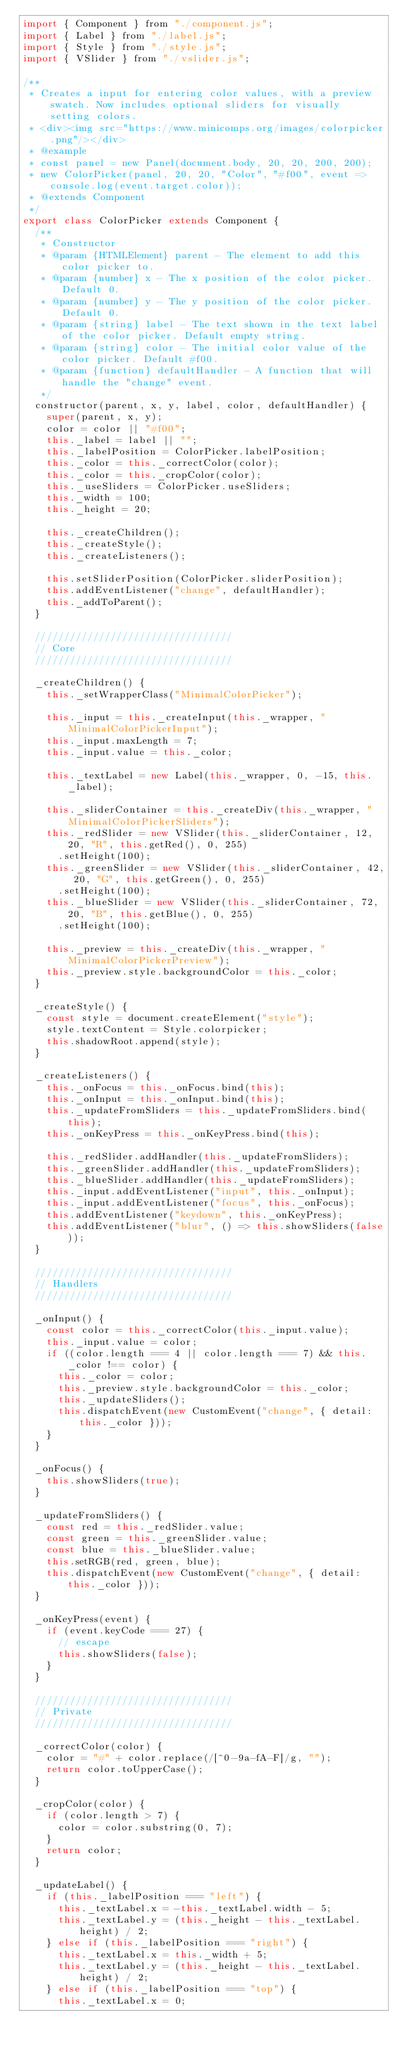<code> <loc_0><loc_0><loc_500><loc_500><_JavaScript_>import { Component } from "./component.js";
import { Label } from "./label.js";
import { Style } from "./style.js";
import { VSlider } from "./vslider.js";

/**
 * Creates a input for entering color values, with a preview swatch. Now includes optional sliders for visually setting colors.
 * <div><img src="https://www.minicomps.org/images/colorpicker.png"/></div>
 * @example
 * const panel = new Panel(document.body, 20, 20, 200, 200);
 * new ColorPicker(panel, 20, 20, "Color", "#f00", event => console.log(event.target.color));
 * @extends Component
 */
export class ColorPicker extends Component {
  /**
   * Constructor
   * @param {HTMLElement} parent - The element to add this color picker to.
   * @param {number} x - The x position of the color picker. Default 0.
   * @param {number} y - The y position of the color picker. Default 0.
   * @param {string} label - The text shown in the text label of the color picker. Default empty string.
   * @param {string} color - The initial color value of the color picker. Default #f00.
   * @param {function} defaultHandler - A function that will handle the "change" event.
   */
  constructor(parent, x, y, label, color, defaultHandler) {
    super(parent, x, y);
    color = color || "#f00";
    this._label = label || "";
    this._labelPosition = ColorPicker.labelPosition;
    this._color = this._correctColor(color);
    this._color = this._cropColor(color);
    this._useSliders = ColorPicker.useSliders;
    this._width = 100;
    this._height = 20;

    this._createChildren();
    this._createStyle();
    this._createListeners();

    this.setSliderPosition(ColorPicker.sliderPosition);
    this.addEventListener("change", defaultHandler);
    this._addToParent();
  }

  //////////////////////////////////
  // Core
  //////////////////////////////////

  _createChildren() {
    this._setWrapperClass("MinimalColorPicker");

    this._input = this._createInput(this._wrapper, "MinimalColorPickerInput");
    this._input.maxLength = 7;
    this._input.value = this._color;

    this._textLabel = new Label(this._wrapper, 0, -15, this._label);

    this._sliderContainer = this._createDiv(this._wrapper, "MinimalColorPickerSliders");
    this._redSlider = new VSlider(this._sliderContainer, 12, 20, "R", this.getRed(), 0, 255)
      .setHeight(100);
    this._greenSlider = new VSlider(this._sliderContainer, 42, 20, "G", this.getGreen(), 0, 255)
      .setHeight(100);
    this._blueSlider = new VSlider(this._sliderContainer, 72, 20, "B", this.getBlue(), 0, 255)
      .setHeight(100);

    this._preview = this._createDiv(this._wrapper, "MinimalColorPickerPreview");
    this._preview.style.backgroundColor = this._color;
  }

  _createStyle() {
    const style = document.createElement("style");
    style.textContent = Style.colorpicker;
    this.shadowRoot.append(style);
  }

  _createListeners() {
    this._onFocus = this._onFocus.bind(this);
    this._onInput = this._onInput.bind(this);
    this._updateFromSliders = this._updateFromSliders.bind(this);
    this._onKeyPress = this._onKeyPress.bind(this);

    this._redSlider.addHandler(this._updateFromSliders);
    this._greenSlider.addHandler(this._updateFromSliders);
    this._blueSlider.addHandler(this._updateFromSliders);
    this._input.addEventListener("input", this._onInput);
    this._input.addEventListener("focus", this._onFocus);
    this.addEventListener("keydown", this._onKeyPress);
    this.addEventListener("blur", () => this.showSliders(false));
  }

  //////////////////////////////////
  // Handlers
  //////////////////////////////////

  _onInput() {
    const color = this._correctColor(this._input.value);
    this._input.value = color;
    if ((color.length === 4 || color.length === 7) && this._color !== color) {
      this._color = color;
      this._preview.style.backgroundColor = this._color;
      this._updateSliders();
      this.dispatchEvent(new CustomEvent("change", { detail: this._color }));
    }
  }

  _onFocus() {
    this.showSliders(true);
  }

  _updateFromSliders() {
    const red = this._redSlider.value;
    const green = this._greenSlider.value;
    const blue = this._blueSlider.value;
    this.setRGB(red, green, blue);
    this.dispatchEvent(new CustomEvent("change", { detail: this._color }));
  }

  _onKeyPress(event) {
    if (event.keyCode === 27) {
      // escape
      this.showSliders(false);
    }
  }

  //////////////////////////////////
  // Private
  //////////////////////////////////

  _correctColor(color) {
    color = "#" + color.replace(/[^0-9a-fA-F]/g, "");
    return color.toUpperCase();
  }

  _cropColor(color) {
    if (color.length > 7) {
      color = color.substring(0, 7);
    }
    return color;
  }

  _updateLabel() {
    if (this._labelPosition === "left") {
      this._textLabel.x = -this._textLabel.width - 5;
      this._textLabel.y = (this._height - this._textLabel.height) / 2;
    } else if (this._labelPosition === "right") {
      this._textLabel.x = this._width + 5;
      this._textLabel.y = (this._height - this._textLabel.height) / 2;
    } else if (this._labelPosition === "top") {
      this._textLabel.x = 0;</code> 